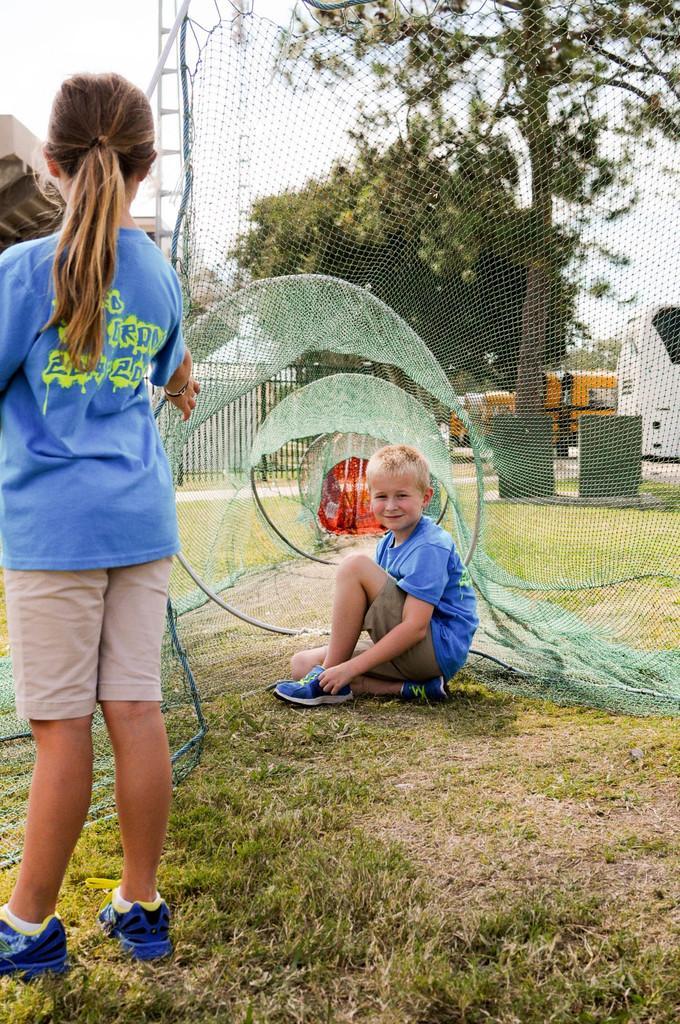How would you summarize this image in a sentence or two? In this image in front there are two people. In front of them there is a net. At the center of the image there is a metal fence. In the background of the image there are trees, vehicles, buildings and sky. 